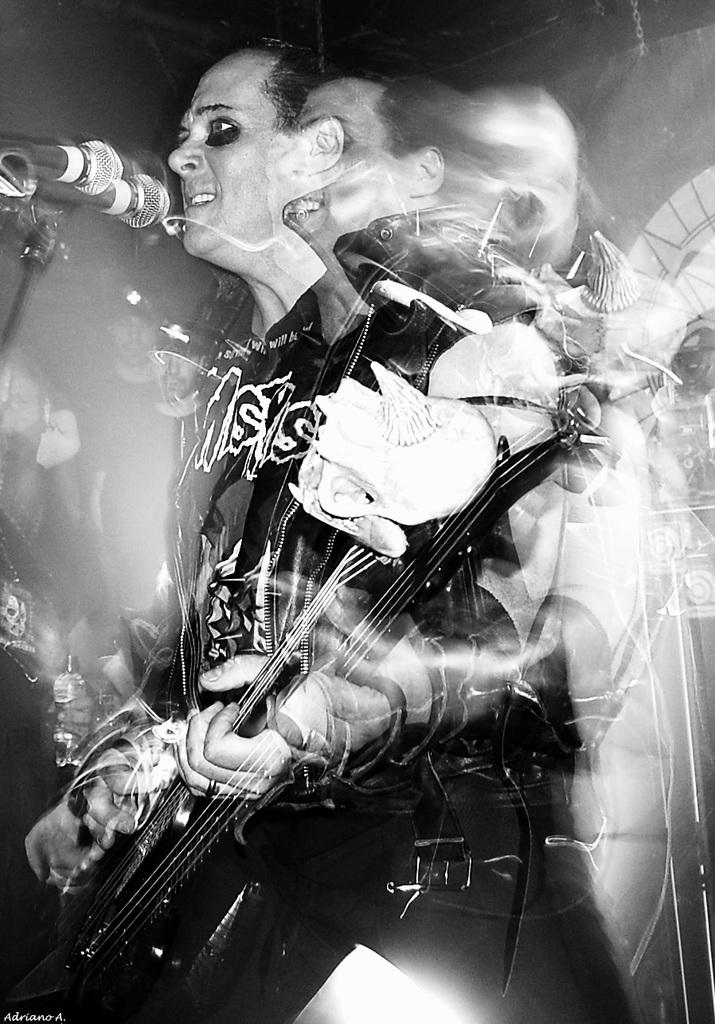What is the main subject of the image? There is a person in the image. What is the person doing in the image? The person is standing, playing a guitar, singing, and using a microphone. What type of hobbies does the person have related to fishing in the image? There is no mention of fishing or any related hobbies in the image. 